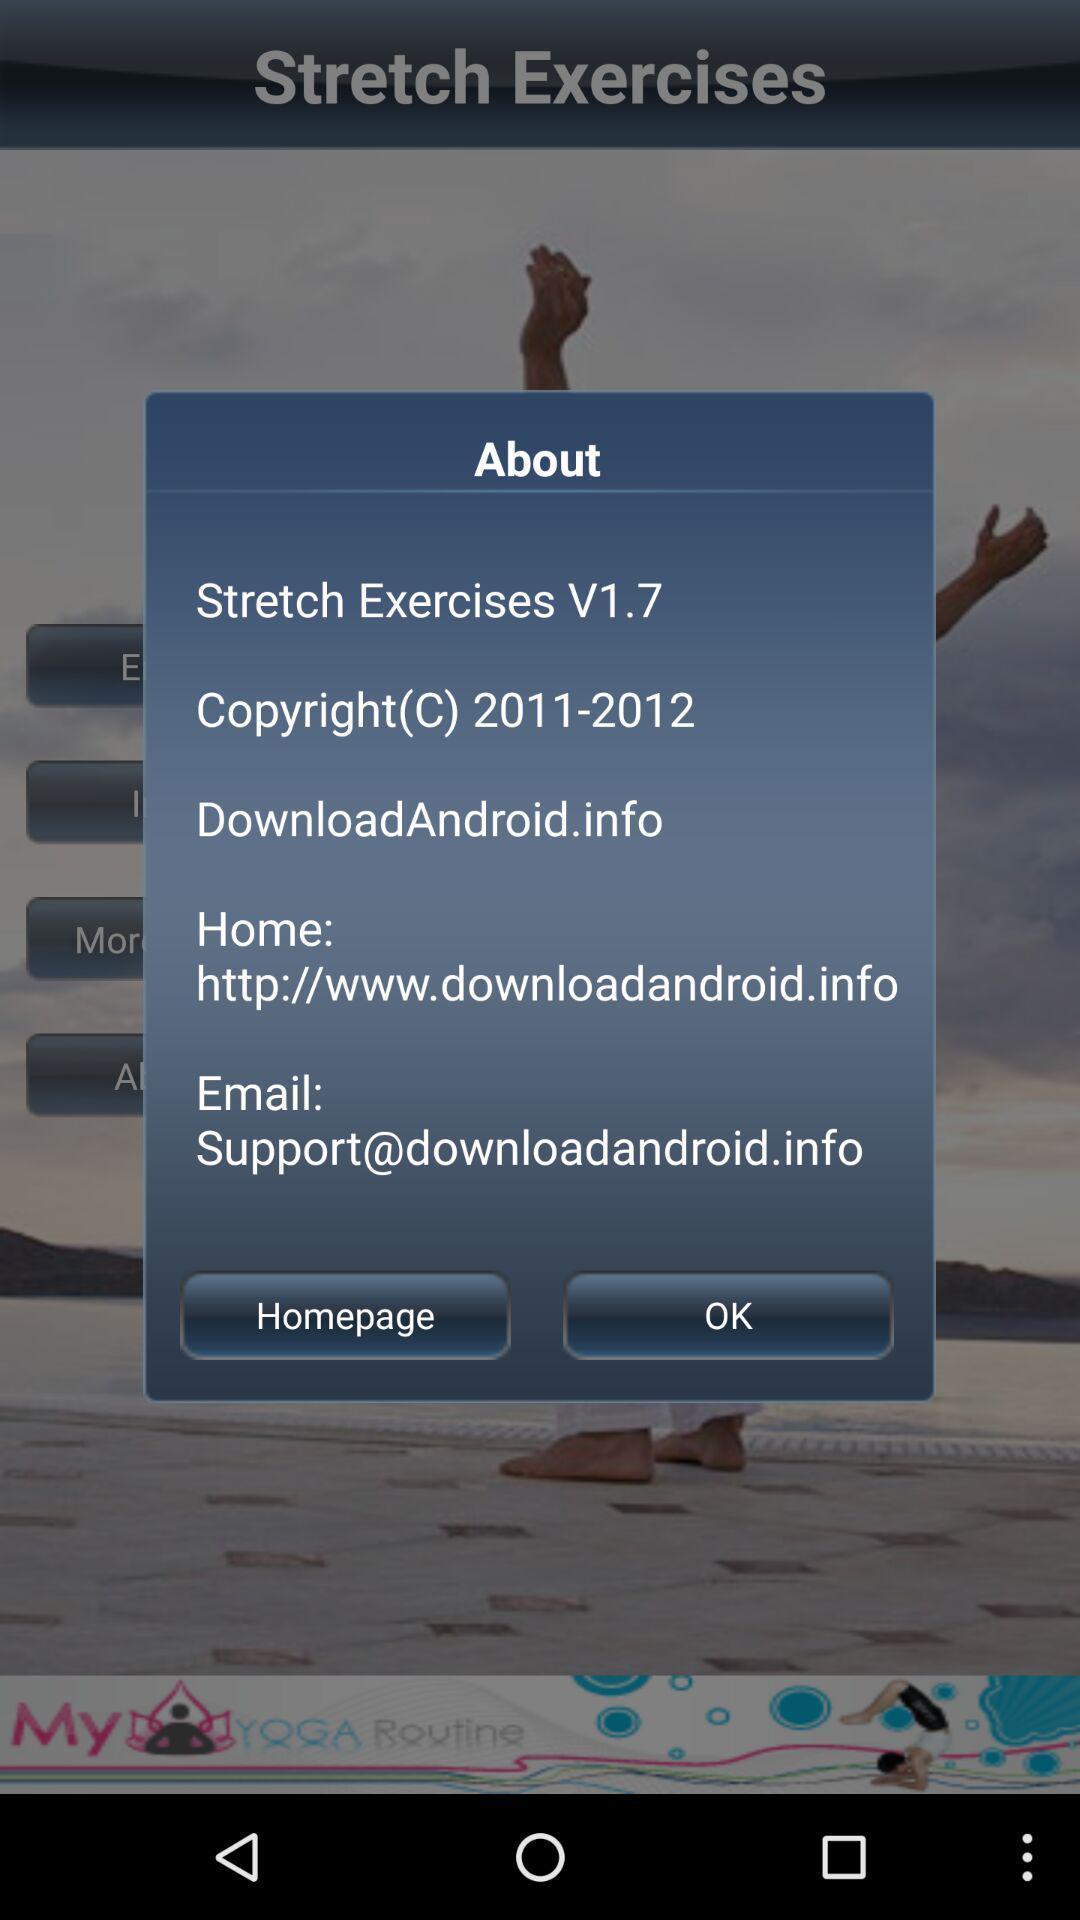Explain what's happening in this screen capture. Screen shows about latest update version. 